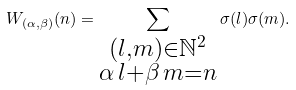Convert formula to latex. <formula><loc_0><loc_0><loc_500><loc_500>W _ { ( \alpha , \beta ) } ( n ) = \sum _ { \substack { { ( l , m ) \in \mathbb { N } ^ { 2 } } \\ { \alpha \, l + \beta \, m = n } } } \sigma ( l ) \sigma ( m ) .</formula> 